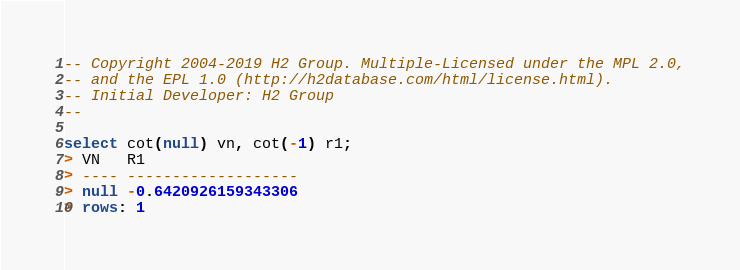Convert code to text. <code><loc_0><loc_0><loc_500><loc_500><_SQL_>-- Copyright 2004-2019 H2 Group. Multiple-Licensed under the MPL 2.0,
-- and the EPL 1.0 (http://h2database.com/html/license.html).
-- Initial Developer: H2 Group
--

select cot(null) vn, cot(-1) r1;
> VN   R1
> ---- -------------------
> null -0.6420926159343306
> rows: 1
</code> 